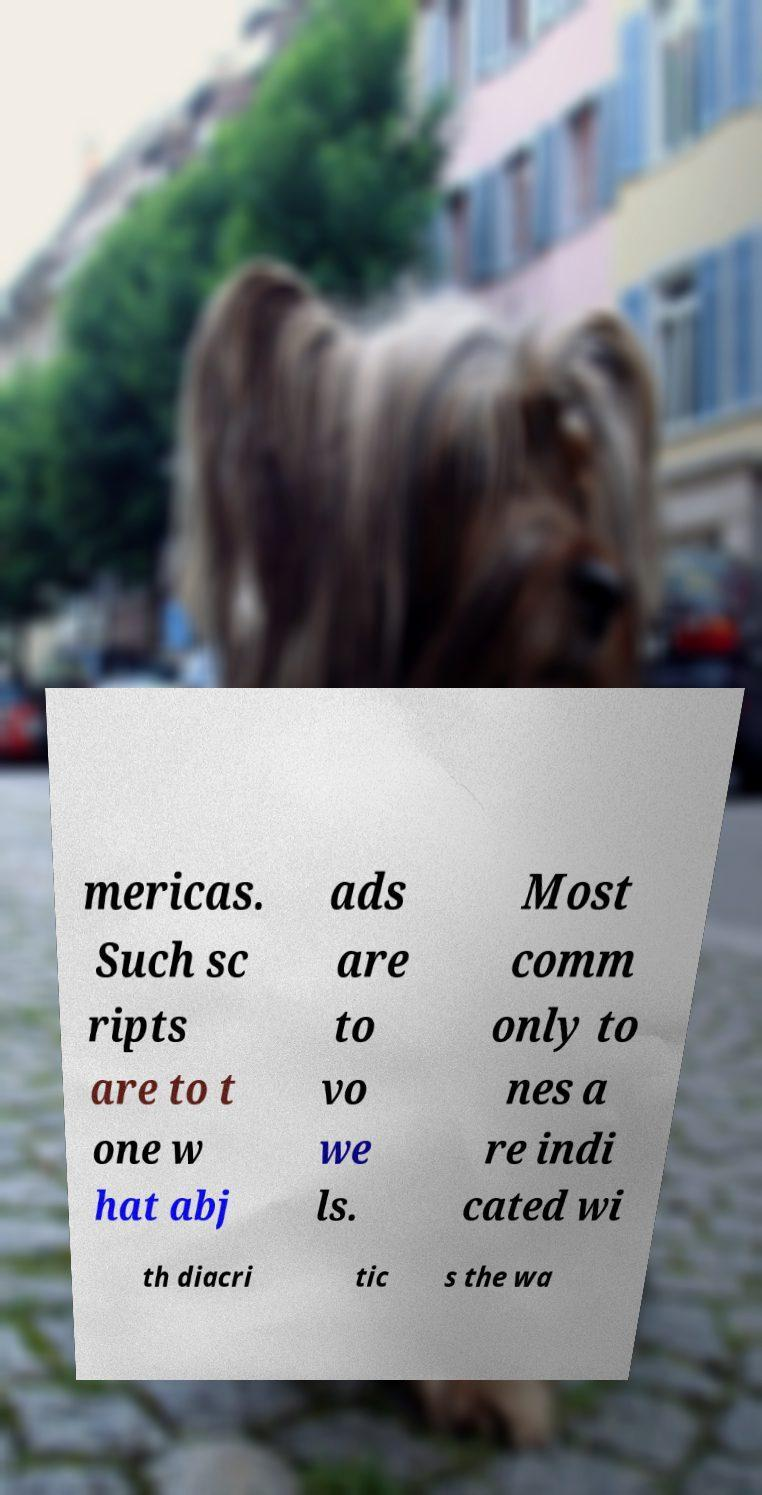What messages or text are displayed in this image? I need them in a readable, typed format. mericas. Such sc ripts are to t one w hat abj ads are to vo we ls. Most comm only to nes a re indi cated wi th diacri tic s the wa 